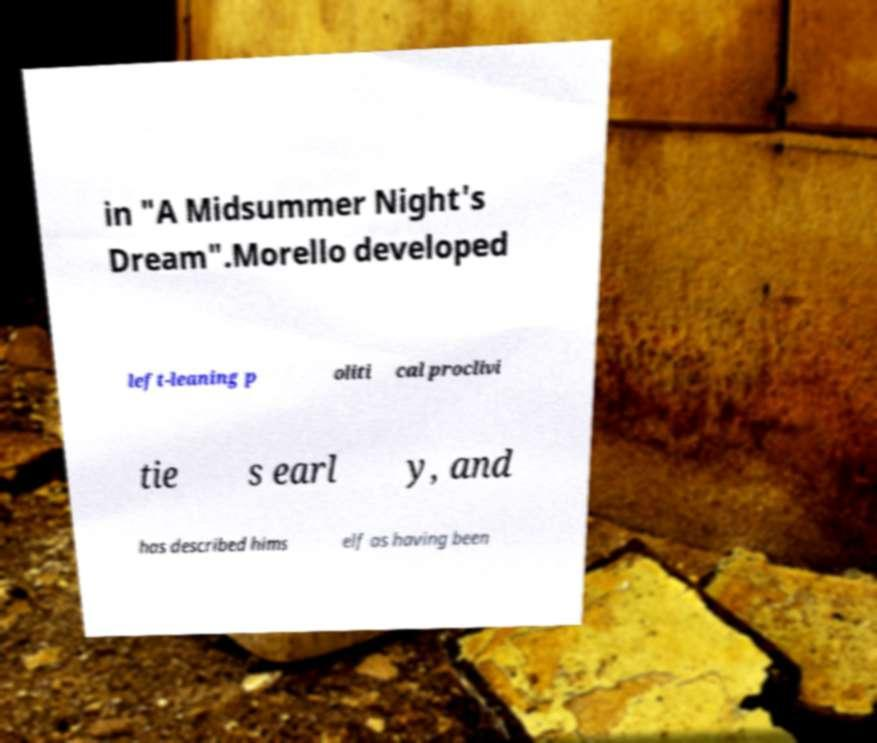There's text embedded in this image that I need extracted. Can you transcribe it verbatim? in "A Midsummer Night's Dream".Morello developed left-leaning p oliti cal proclivi tie s earl y, and has described hims elf as having been 